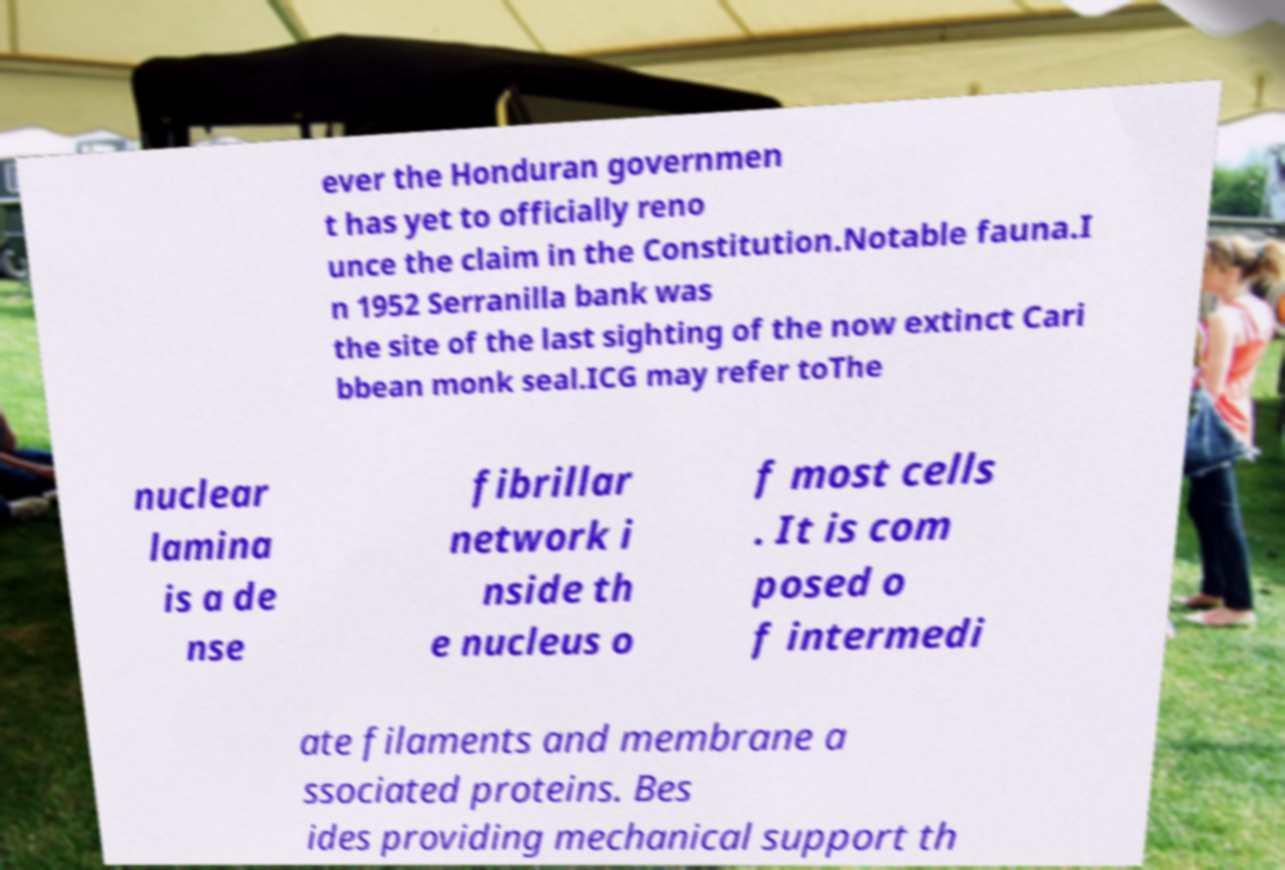Please read and relay the text visible in this image. What does it say? ever the Honduran governmen t has yet to officially reno unce the claim in the Constitution.Notable fauna.I n 1952 Serranilla bank was the site of the last sighting of the now extinct Cari bbean monk seal.ICG may refer toThe nuclear lamina is a de nse fibrillar network i nside th e nucleus o f most cells . It is com posed o f intermedi ate filaments and membrane a ssociated proteins. Bes ides providing mechanical support th 